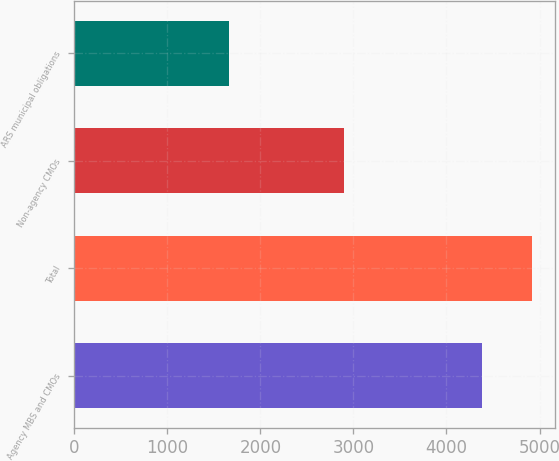Convert chart. <chart><loc_0><loc_0><loc_500><loc_500><bar_chart><fcel>Agency MBS and CMOs<fcel>Total<fcel>Non-agency CMOs<fcel>ARS municipal obligations<nl><fcel>4378<fcel>4921<fcel>2896<fcel>1661<nl></chart> 